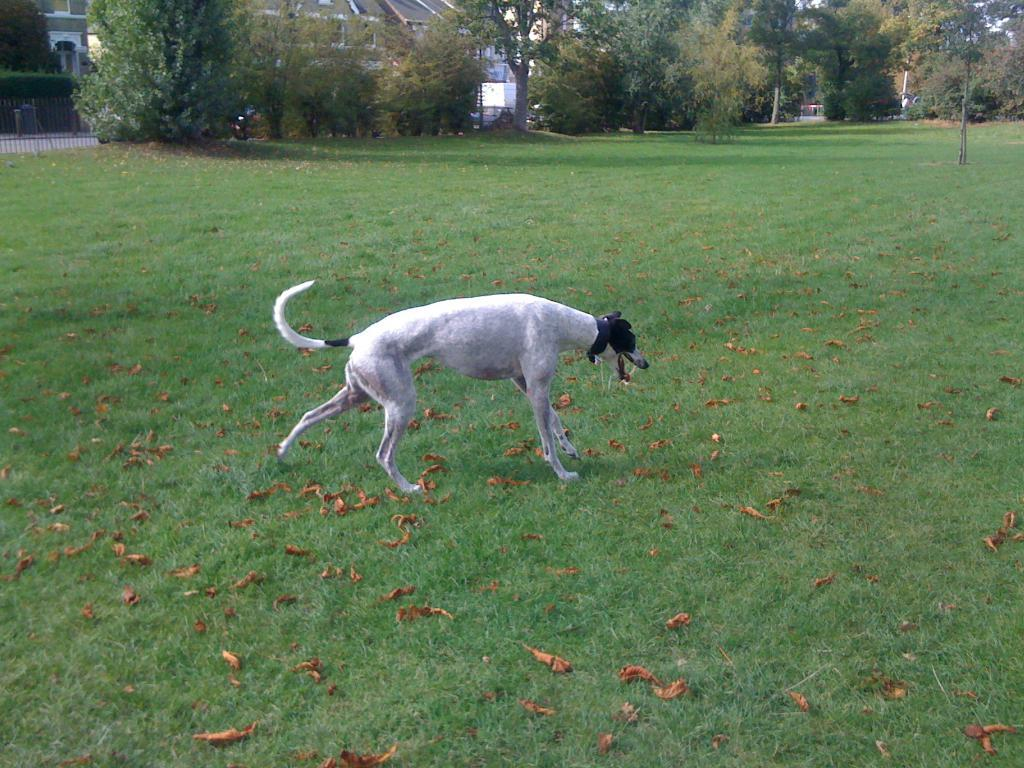What animal is on the ground in the image? There is a dog on the ground in the image. What type of surface is the dog standing on? The ground has grass. What can be seen in the distance behind the dog? There are many trees and buildings in the background. What type of attraction is the dog visiting in the image? There is no indication of an attraction in the image; it simply shows a dog on grass with trees and buildings in the background. 